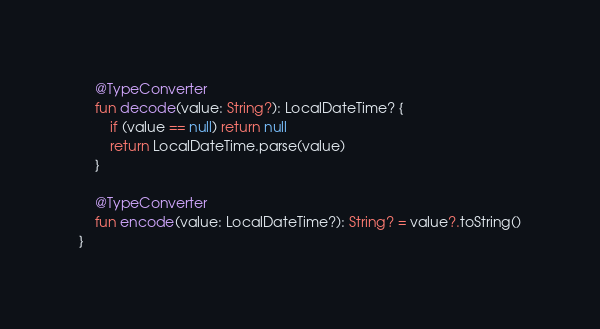Convert code to text. <code><loc_0><loc_0><loc_500><loc_500><_Kotlin_>    @TypeConverter
    fun decode(value: String?): LocalDateTime? {
        if (value == null) return null
        return LocalDateTime.parse(value)
    }

    @TypeConverter
    fun encode(value: LocalDateTime?): String? = value?.toString()
}</code> 